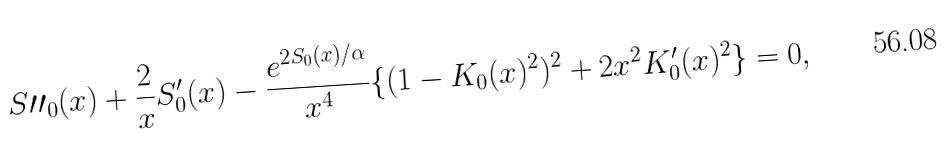Convert formula to latex. <formula><loc_0><loc_0><loc_500><loc_500>S \prime \prime _ { 0 } ( x ) + \frac { 2 } { x } S _ { 0 } ^ { \prime } ( x ) - \frac { e ^ { 2 S _ { 0 } ( x ) / \alpha } } { x ^ { 4 } } \{ ( 1 - K _ { 0 } ( x ) ^ { 2 } ) ^ { 2 } + 2 x ^ { 2 } K _ { 0 } ^ { \prime } ( x ) ^ { 2 } \} = 0 ,</formula> 